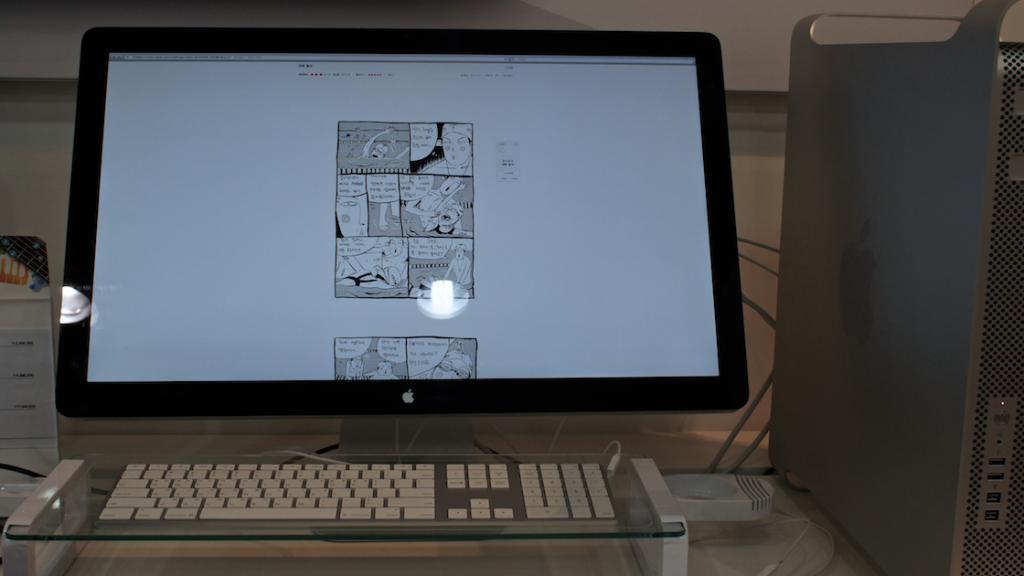Please provide a concise description of this image. In this picture I can observe computer placed on the desk in the middle of the picture. I can observe an image in the screen of a monitor. 